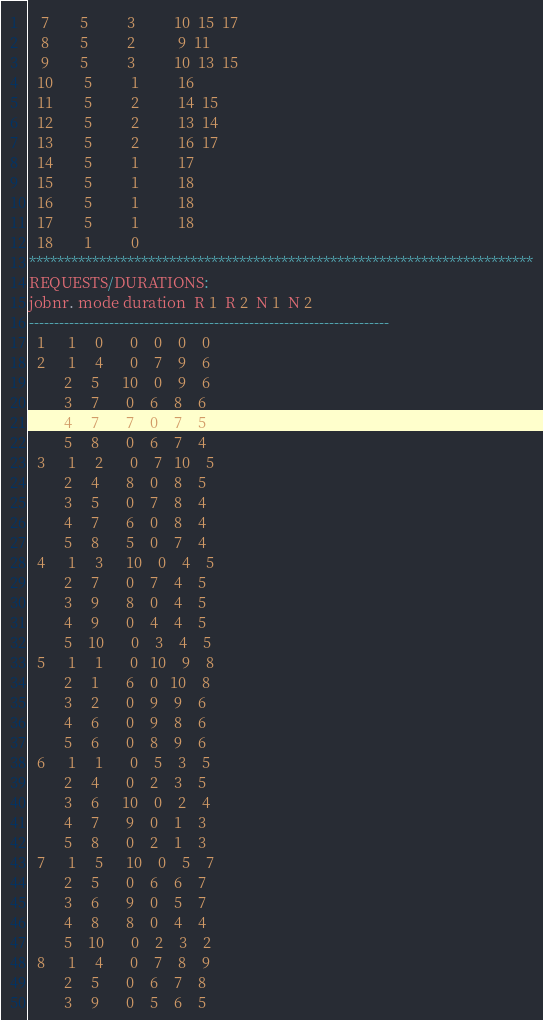Convert code to text. <code><loc_0><loc_0><loc_500><loc_500><_ObjectiveC_>   7        5          3          10  15  17
   8        5          2           9  11
   9        5          3          10  13  15
  10        5          1          16
  11        5          2          14  15
  12        5          2          13  14
  13        5          2          16  17
  14        5          1          17
  15        5          1          18
  16        5          1          18
  17        5          1          18
  18        1          0        
************************************************************************
REQUESTS/DURATIONS:
jobnr. mode duration  R 1  R 2  N 1  N 2
------------------------------------------------------------------------
  1      1     0       0    0    0    0
  2      1     4       0    7    9    6
         2     5      10    0    9    6
         3     7       0    6    8    6
         4     7       7    0    7    5
         5     8       0    6    7    4
  3      1     2       0    7   10    5
         2     4       8    0    8    5
         3     5       0    7    8    4
         4     7       6    0    8    4
         5     8       5    0    7    4
  4      1     3      10    0    4    5
         2     7       0    7    4    5
         3     9       8    0    4    5
         4     9       0    4    4    5
         5    10       0    3    4    5
  5      1     1       0   10    9    8
         2     1       6    0   10    8
         3     2       0    9    9    6
         4     6       0    9    8    6
         5     6       0    8    9    6
  6      1     1       0    5    3    5
         2     4       0    2    3    5
         3     6      10    0    2    4
         4     7       9    0    1    3
         5     8       0    2    1    3
  7      1     5      10    0    5    7
         2     5       0    6    6    7
         3     6       9    0    5    7
         4     8       8    0    4    4
         5    10       0    2    3    2
  8      1     4       0    7    8    9
         2     5       0    6    7    8
         3     9       0    5    6    5</code> 